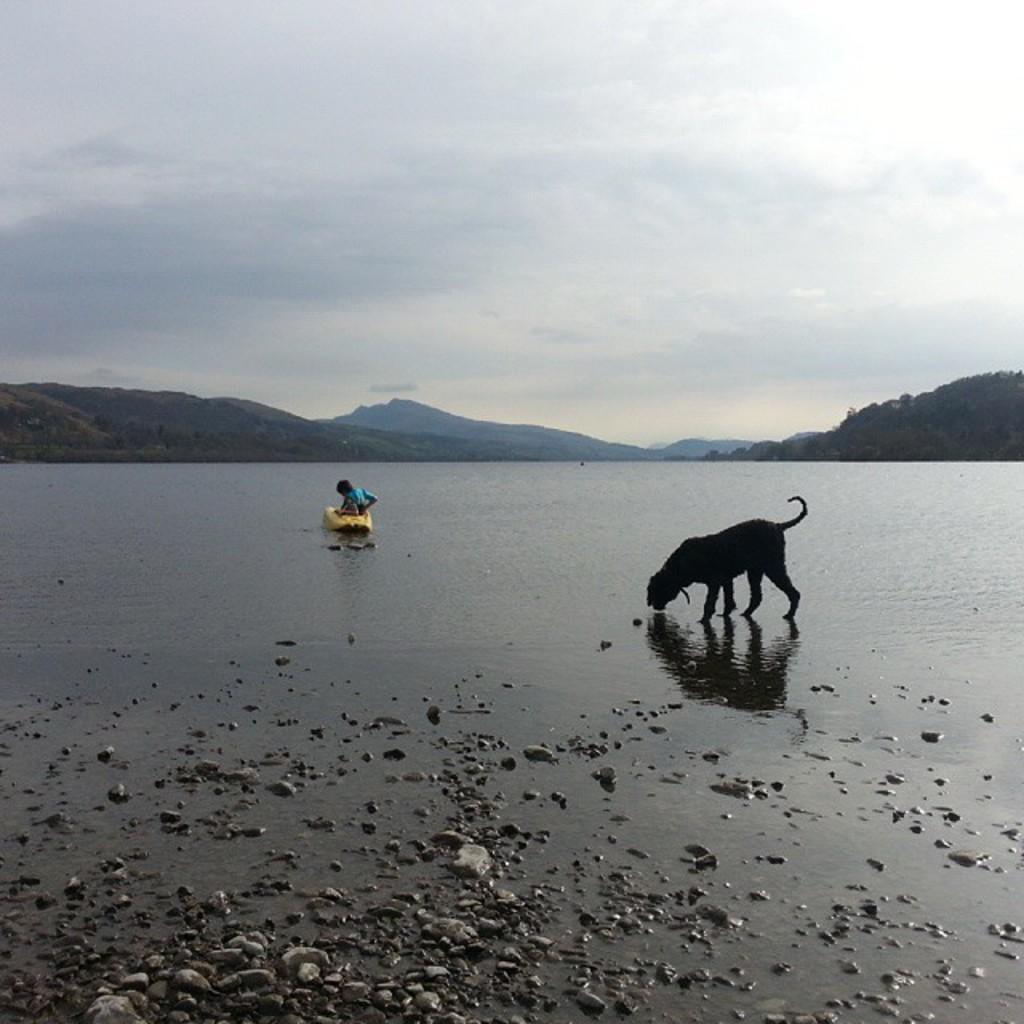Please provide a concise description of this image. In this image, there is an outside view. There is a dog beside the lake. There are mountains in the middle of the image. In the background of the image, there is a sky. 